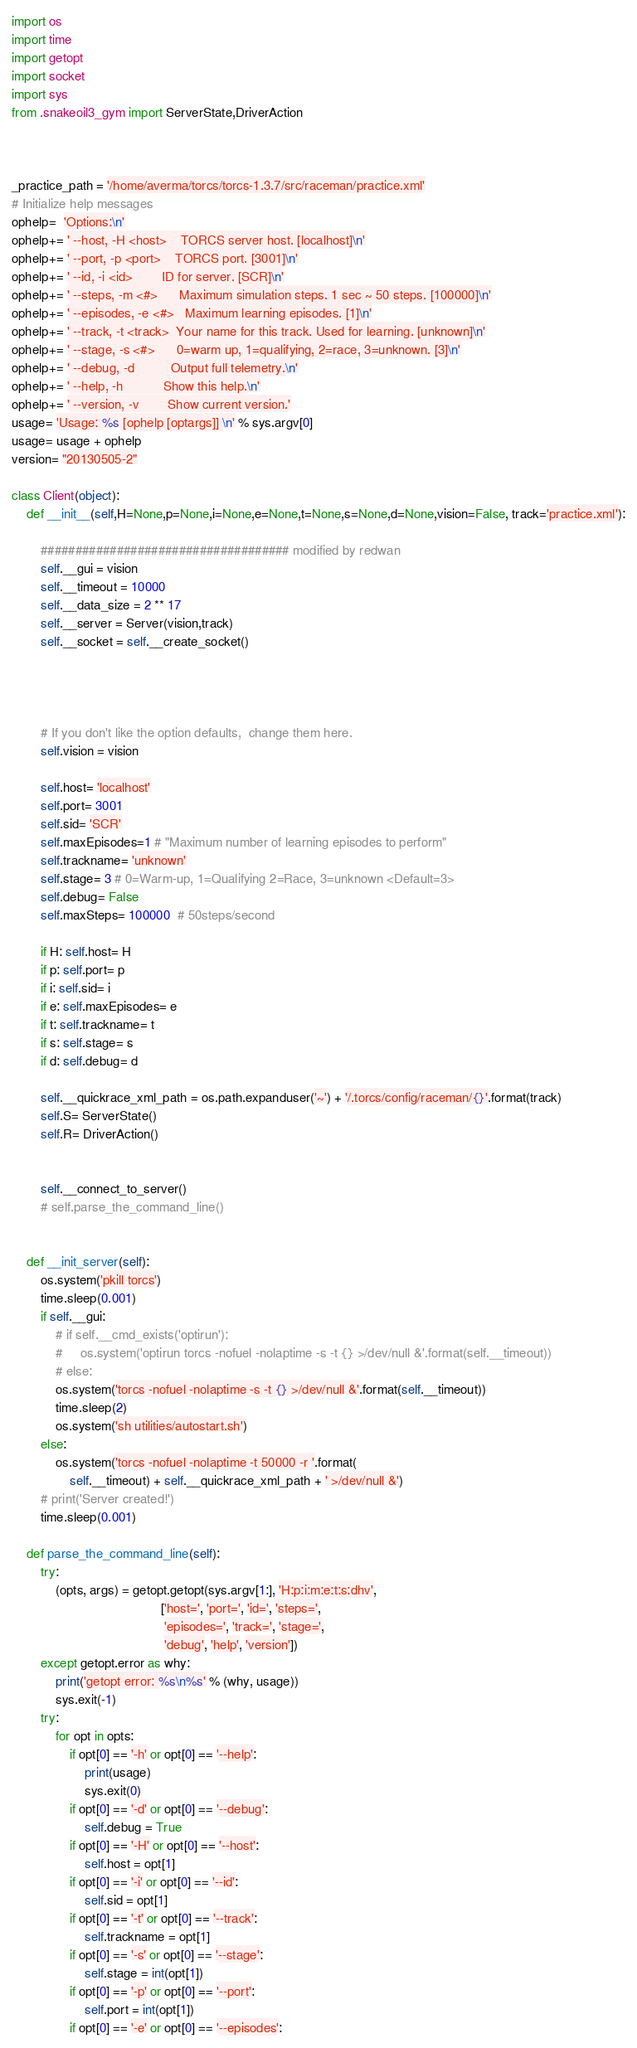Convert code to text. <code><loc_0><loc_0><loc_500><loc_500><_Python_>import os
import time
import getopt
import socket
import sys
from .snakeoil3_gym import ServerState,DriverAction



_practice_path = '/home/averma/torcs/torcs-1.3.7/src/raceman/practice.xml'
# Initialize help messages
ophelp=  'Options:\n'
ophelp+= ' --host, -H <host>    TORCS server host. [localhost]\n'
ophelp+= ' --port, -p <port>    TORCS port. [3001]\n'
ophelp+= ' --id, -i <id>        ID for server. [SCR]\n'
ophelp+= ' --steps, -m <#>      Maximum simulation steps. 1 sec ~ 50 steps. [100000]\n'
ophelp+= ' --episodes, -e <#>   Maximum learning episodes. [1]\n'
ophelp+= ' --track, -t <track>  Your name for this track. Used for learning. [unknown]\n'
ophelp+= ' --stage, -s <#>      0=warm up, 1=qualifying, 2=race, 3=unknown. [3]\n'
ophelp+= ' --debug, -d          Output full telemetry.\n'
ophelp+= ' --help, -h           Show this help.\n'
ophelp+= ' --version, -v        Show current version.'
usage= 'Usage: %s [ophelp [optargs]] \n' % sys.argv[0]
usage= usage + ophelp
version= "20130505-2"

class Client(object):
    def __init__(self,H=None,p=None,i=None,e=None,t=None,s=None,d=None,vision=False, track='practice.xml'):

        #################################### modified by redwan
        self.__gui = vision
        self.__timeout = 10000
        self.__data_size = 2 ** 17
        self.__server = Server(vision,track)
        self.__socket = self.__create_socket()




        # If you don't like the option defaults,  change them here.
        self.vision = vision

        self.host= 'localhost'
        self.port= 3001
        self.sid= 'SCR'
        self.maxEpisodes=1 # "Maximum number of learning episodes to perform"
        self.trackname= 'unknown'
        self.stage= 3 # 0=Warm-up, 1=Qualifying 2=Race, 3=unknown <Default=3>
        self.debug= False
        self.maxSteps= 100000  # 50steps/second

        if H: self.host= H
        if p: self.port= p
        if i: self.sid= i
        if e: self.maxEpisodes= e
        if t: self.trackname= t
        if s: self.stage= s
        if d: self.debug= d

        self.__quickrace_xml_path = os.path.expanduser('~') + '/.torcs/config/raceman/{}'.format(track)
        self.S= ServerState()
        self.R= DriverAction()


        self.__connect_to_server()
        # self.parse_the_command_line()


    def __init_server(self):
        os.system('pkill torcs')
        time.sleep(0.001)
        if self.__gui:
            # if self.__cmd_exists('optirun'):
            #     os.system('optirun torcs -nofuel -nolaptime -s -t {} >/dev/null &'.format(self.__timeout))
            # else:
            os.system('torcs -nofuel -nolaptime -s -t {} >/dev/null &'.format(self.__timeout))
            time.sleep(2)
            os.system('sh utilities/autostart.sh')
        else:
            os.system('torcs -nofuel -nolaptime -t 50000 -r '.format(
                self.__timeout) + self.__quickrace_xml_path + ' >/dev/null &')
        # print('Server created!')
        time.sleep(0.001)

    def parse_the_command_line(self):
        try:
            (opts, args) = getopt.getopt(sys.argv[1:], 'H:p:i:m:e:t:s:dhv',
                                         ['host=', 'port=', 'id=', 'steps=',
                                          'episodes=', 'track=', 'stage=',
                                          'debug', 'help', 'version'])
        except getopt.error as why:
            print('getopt error: %s\n%s' % (why, usage))
            sys.exit(-1)
        try:
            for opt in opts:
                if opt[0] == '-h' or opt[0] == '--help':
                    print(usage)
                    sys.exit(0)
                if opt[0] == '-d' or opt[0] == '--debug':
                    self.debug = True
                if opt[0] == '-H' or opt[0] == '--host':
                    self.host = opt[1]
                if opt[0] == '-i' or opt[0] == '--id':
                    self.sid = opt[1]
                if opt[0] == '-t' or opt[0] == '--track':
                    self.trackname = opt[1]
                if opt[0] == '-s' or opt[0] == '--stage':
                    self.stage = int(opt[1])
                if opt[0] == '-p' or opt[0] == '--port':
                    self.port = int(opt[1])
                if opt[0] == '-e' or opt[0] == '--episodes':</code> 